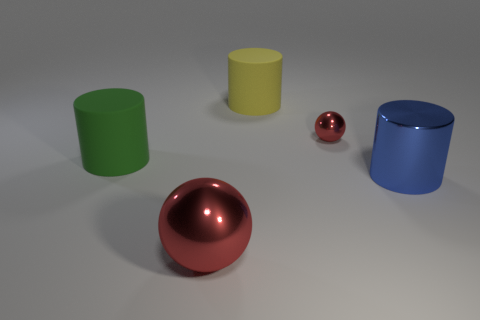What material is the big green thing that is behind the blue cylinder?
Your answer should be compact. Rubber. The object that is the same color as the big metal ball is what size?
Your answer should be compact. Small. There is a shiny ball in front of the large green matte object; is it the same color as the metal ball that is right of the large red thing?
Your response must be concise. Yes. Do the big cylinder that is behind the tiny shiny ball and the red sphere right of the yellow matte object have the same material?
Provide a short and direct response. No. What material is the large cylinder that is both right of the big metal sphere and behind the shiny cylinder?
Your answer should be compact. Rubber. There is a tiny red object that is the same material as the large blue cylinder; what is its shape?
Ensure brevity in your answer.  Sphere. Is the number of yellow cylinders in front of the big blue cylinder the same as the number of matte cylinders that are on the right side of the large red sphere?
Offer a terse response. No. Do the tiny red ball and the big yellow cylinder have the same material?
Offer a very short reply. No. There is a cylinder that is to the right of the tiny shiny sphere; is there a large cylinder that is on the left side of it?
Offer a terse response. Yes. Is there a large yellow rubber object of the same shape as the big blue metallic thing?
Your response must be concise. Yes. 